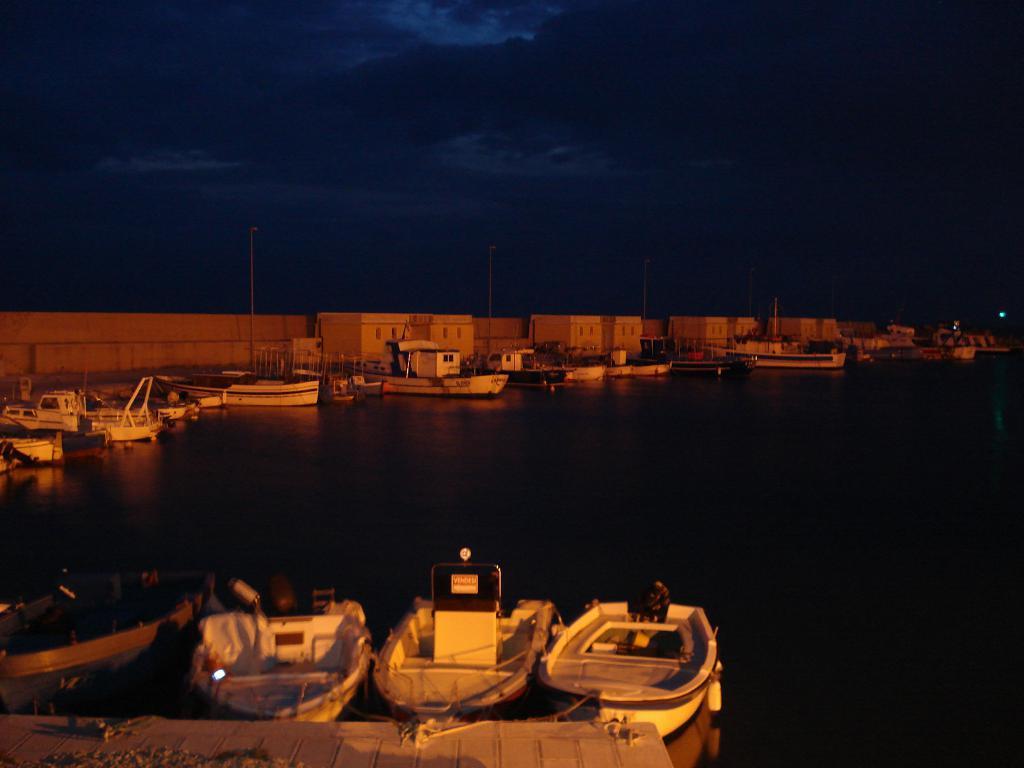Can you describe this image briefly? In the image we can see there are boats standing on the ground and behind there are buildings. 